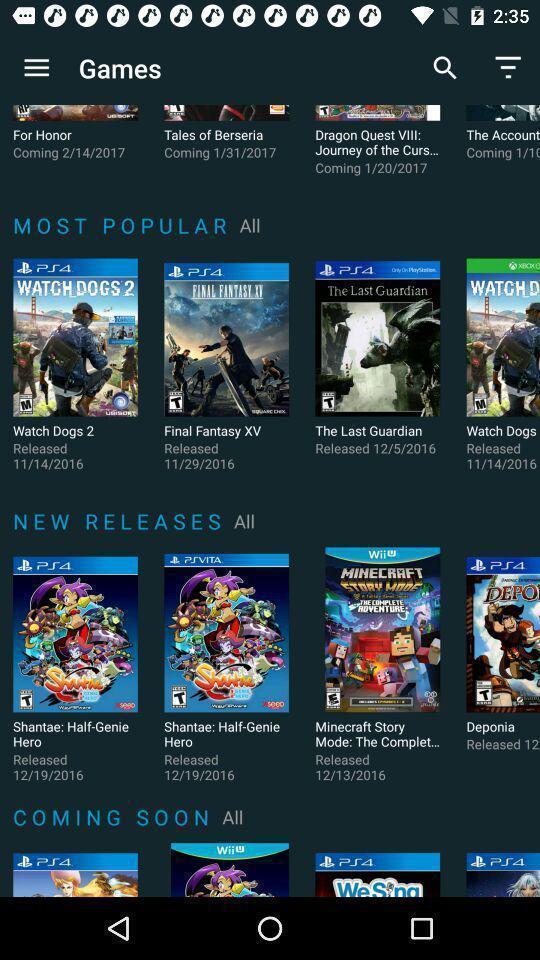Tell me what you see in this picture. Screen shows multiple options in gaming application. 